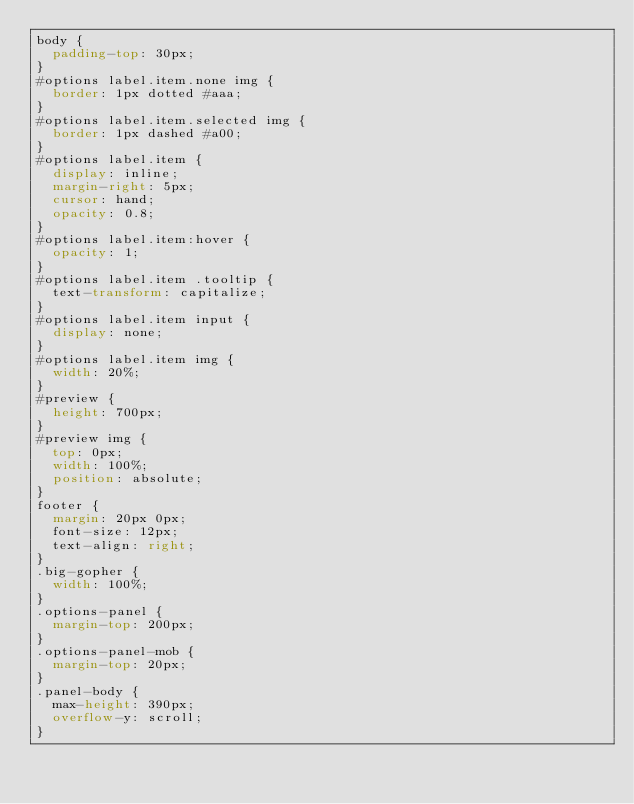<code> <loc_0><loc_0><loc_500><loc_500><_CSS_>body {
  padding-top: 30px;
}
#options label.item.none img {
  border: 1px dotted #aaa;
}
#options label.item.selected img {
  border: 1px dashed #a00;
}
#options label.item {
  display: inline;
  margin-right: 5px;
  cursor: hand;
  opacity: 0.8;
}
#options label.item:hover {
  opacity: 1;
}
#options label.item .tooltip {
  text-transform: capitalize;
}
#options label.item input {
  display: none;
}
#options label.item img {
  width: 20%;
}
#preview {
  height: 700px;
}
#preview img {
  top: 0px;
  width: 100%;
  position: absolute;
}
footer {
  margin: 20px 0px;
  font-size: 12px;
  text-align: right;
}
.big-gopher {
  width: 100%;
}
.options-panel {
  margin-top: 200px;
}
.options-panel-mob {
  margin-top: 20px;
}
.panel-body {
  max-height: 390px;
  overflow-y: scroll;
}
</code> 